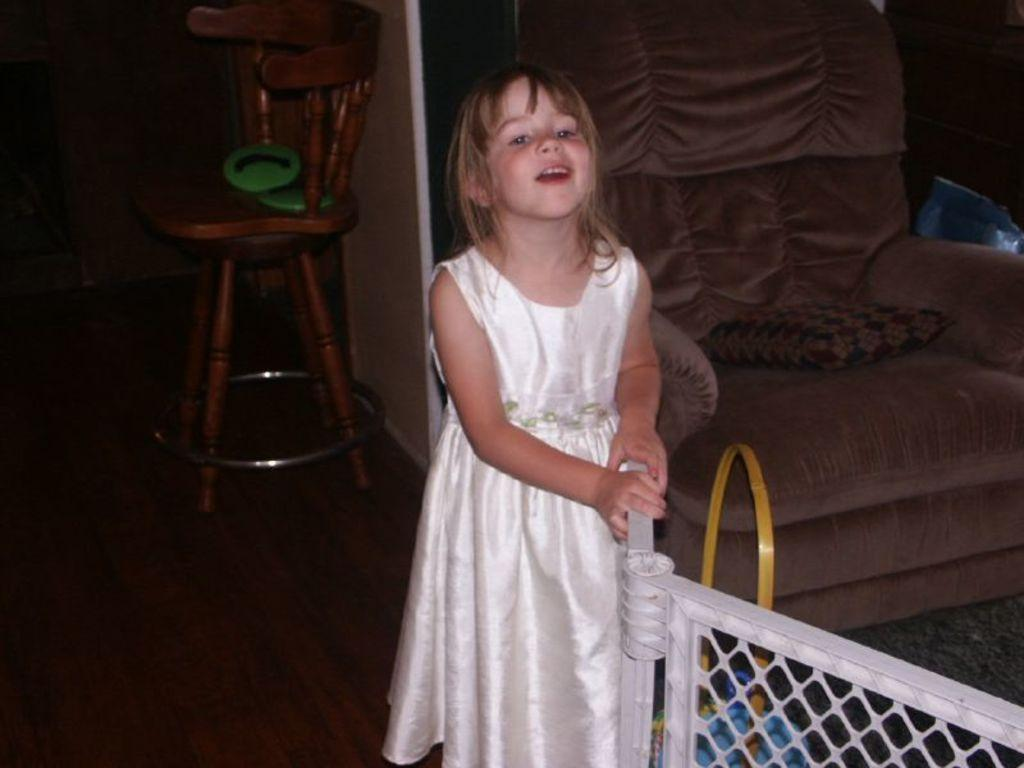What is the main subject of the image? There is a girl standing in the image. What can be seen in the background of the image? There is a chair, a wall, and a couch in the background of the image. What type of plantation can be seen in the background of the image? There is no plantation present in the image; it features a girl standing in front of a chair, wall, and couch. Does the girl have a brother in the image? The provided facts do not mention the presence of a brother in the image. 